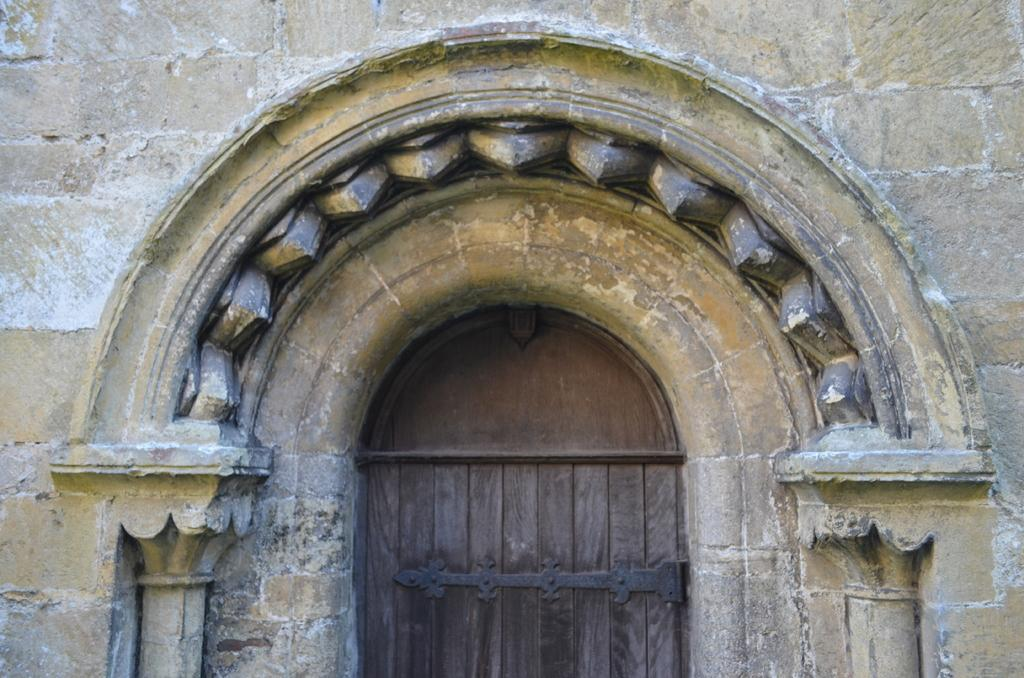What is the main object in the image? There is a door in the image. What does the door lead to? The door leads to a building. What type of interest is being paid on the door in the image? There is no mention of interest or any financial aspect in the image; it simply features a door leading to a building. 